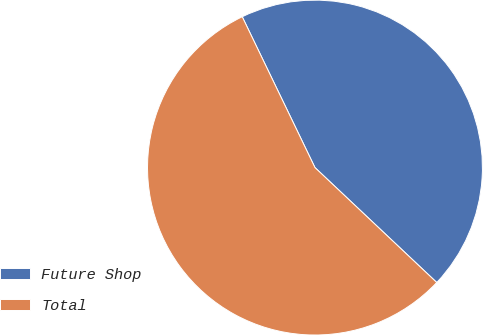Convert chart to OTSL. <chart><loc_0><loc_0><loc_500><loc_500><pie_chart><fcel>Future Shop<fcel>Total<nl><fcel>44.19%<fcel>55.81%<nl></chart> 